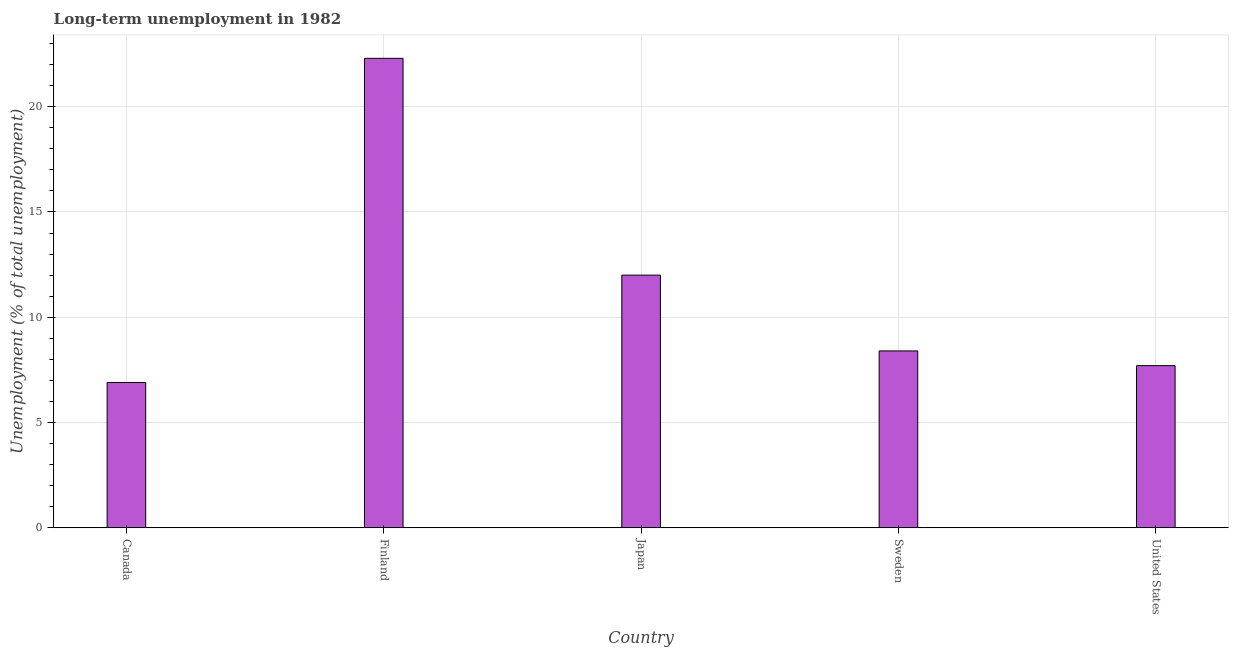What is the title of the graph?
Your answer should be very brief. Long-term unemployment in 1982. What is the label or title of the X-axis?
Offer a terse response. Country. What is the label or title of the Y-axis?
Provide a short and direct response. Unemployment (% of total unemployment). What is the long-term unemployment in Finland?
Your response must be concise. 22.3. Across all countries, what is the maximum long-term unemployment?
Keep it short and to the point. 22.3. Across all countries, what is the minimum long-term unemployment?
Your response must be concise. 6.9. What is the sum of the long-term unemployment?
Keep it short and to the point. 57.3. What is the average long-term unemployment per country?
Your answer should be very brief. 11.46. What is the median long-term unemployment?
Provide a succinct answer. 8.4. What is the ratio of the long-term unemployment in Finland to that in Sweden?
Offer a very short reply. 2.65. What is the difference between the highest and the second highest long-term unemployment?
Offer a very short reply. 10.3. Is the sum of the long-term unemployment in Japan and Sweden greater than the maximum long-term unemployment across all countries?
Your response must be concise. No. In how many countries, is the long-term unemployment greater than the average long-term unemployment taken over all countries?
Make the answer very short. 2. How many countries are there in the graph?
Ensure brevity in your answer.  5. Are the values on the major ticks of Y-axis written in scientific E-notation?
Give a very brief answer. No. What is the Unemployment (% of total unemployment) of Canada?
Your response must be concise. 6.9. What is the Unemployment (% of total unemployment) of Finland?
Your answer should be compact. 22.3. What is the Unemployment (% of total unemployment) in Sweden?
Offer a terse response. 8.4. What is the Unemployment (% of total unemployment) of United States?
Provide a short and direct response. 7.7. What is the difference between the Unemployment (% of total unemployment) in Canada and Finland?
Make the answer very short. -15.4. What is the difference between the Unemployment (% of total unemployment) in Canada and United States?
Keep it short and to the point. -0.8. What is the difference between the Unemployment (% of total unemployment) in Finland and Japan?
Ensure brevity in your answer.  10.3. What is the difference between the Unemployment (% of total unemployment) in Japan and Sweden?
Offer a terse response. 3.6. What is the difference between the Unemployment (% of total unemployment) in Japan and United States?
Keep it short and to the point. 4.3. What is the ratio of the Unemployment (% of total unemployment) in Canada to that in Finland?
Make the answer very short. 0.31. What is the ratio of the Unemployment (% of total unemployment) in Canada to that in Japan?
Give a very brief answer. 0.57. What is the ratio of the Unemployment (% of total unemployment) in Canada to that in Sweden?
Your response must be concise. 0.82. What is the ratio of the Unemployment (% of total unemployment) in Canada to that in United States?
Your answer should be very brief. 0.9. What is the ratio of the Unemployment (% of total unemployment) in Finland to that in Japan?
Keep it short and to the point. 1.86. What is the ratio of the Unemployment (% of total unemployment) in Finland to that in Sweden?
Ensure brevity in your answer.  2.65. What is the ratio of the Unemployment (% of total unemployment) in Finland to that in United States?
Provide a short and direct response. 2.9. What is the ratio of the Unemployment (% of total unemployment) in Japan to that in Sweden?
Provide a short and direct response. 1.43. What is the ratio of the Unemployment (% of total unemployment) in Japan to that in United States?
Ensure brevity in your answer.  1.56. What is the ratio of the Unemployment (% of total unemployment) in Sweden to that in United States?
Your response must be concise. 1.09. 